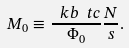<formula> <loc_0><loc_0><loc_500><loc_500>M _ { 0 } \equiv \frac { \ k b \ t c } { \Phi _ { 0 } } \frac { N } { s } .</formula> 